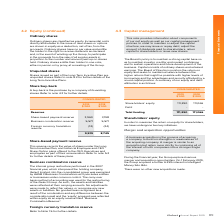From Iselect's financial document, What are the components of reserves? The document contains multiple relevant values: Share-based payment reserve, Business combination reserve, Foreign currency translation reserve. From the document: "Foreign currency translation reserve (12) (24) Share-based payment reserve 3,960 3,198 Business combination reserve 5,571 5,571..." Also, Which method of accounting was used for the restructuring of the iSelect Group? carry-over basis method of accounting. The document states: "entities or businesses under common control. The carry-over basis method of accounting was used for the restructuring of the iSelect Group. As such, t..." Also, What is a buy-back? the purchase by a company of its existing shares. The document states: "A buy-back is the purchase by a company of its existing shares. Refer to note 4.3 for further details...." Additionally, In which year is the share-based payment reserve higher? According to the financial document, 2019. The relevant text states: "2019 $’000 2018 $’000..." Also, can you calculate: What is the change in the Business combination reserve between 2018 and 2019? I cannot find a specific answer to this question in the financial document. Also, can you calculate: What is the percentage change in the total reserves from 2018 to 2019? To answer this question, I need to perform calculations using the financial data. The calculation is: (9,519-8,745)/8,745, which equals 8.85 (percentage). This is based on the information: "9,519 8,745 9,519 8,745..." The key data points involved are: 8,745, 9,519. 